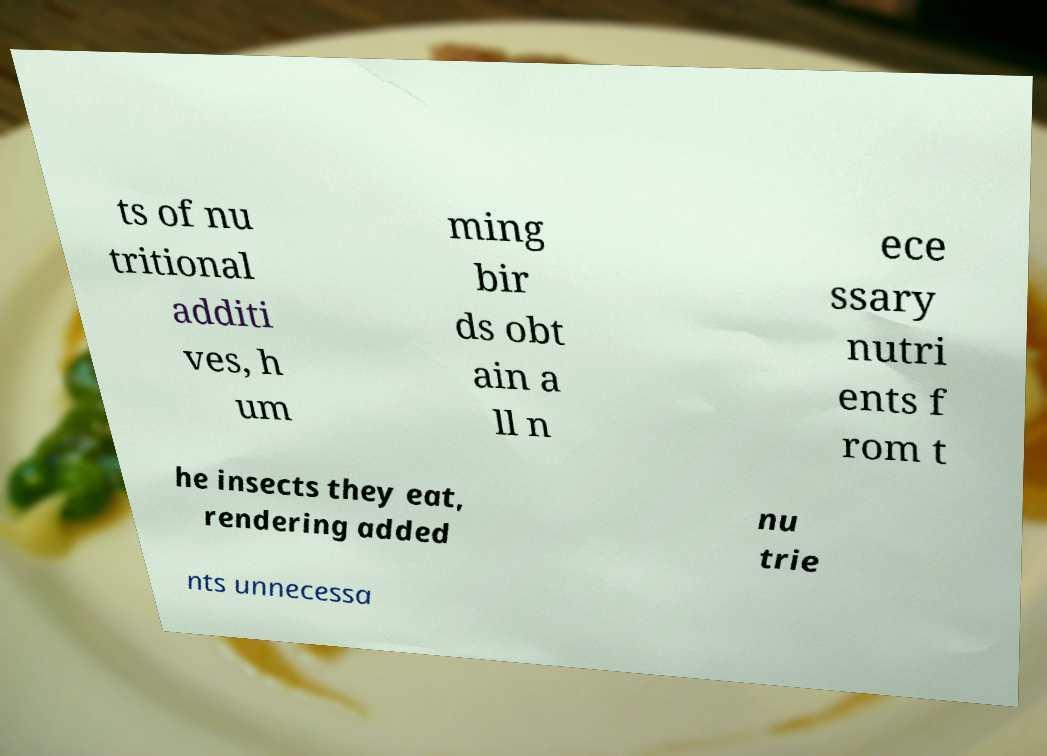Could you extract and type out the text from this image? ts of nu tritional additi ves, h um ming bir ds obt ain a ll n ece ssary nutri ents f rom t he insects they eat, rendering added nu trie nts unnecessa 